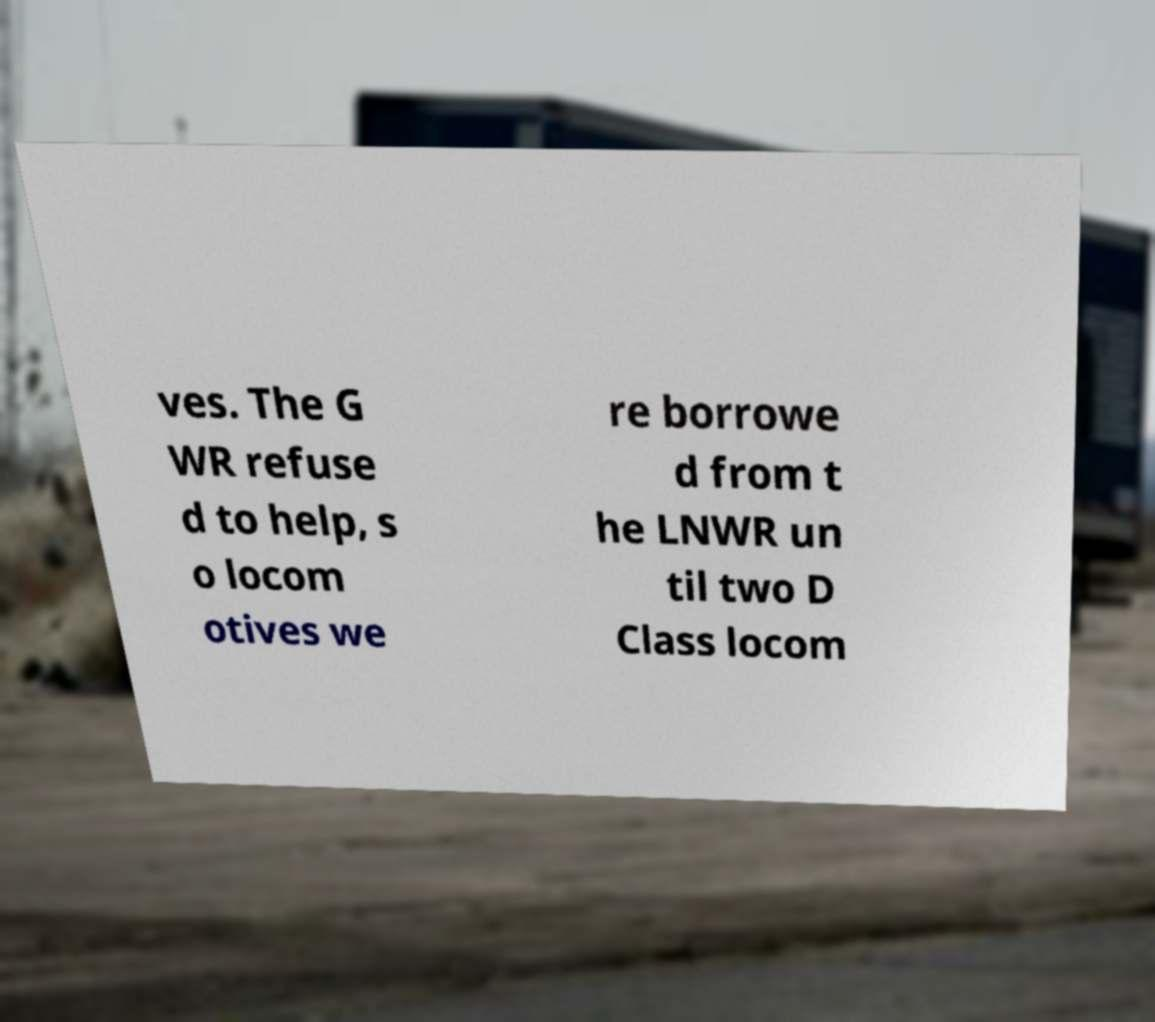Please read and relay the text visible in this image. What does it say? ves. The G WR refuse d to help, s o locom otives we re borrowe d from t he LNWR un til two D Class locom 